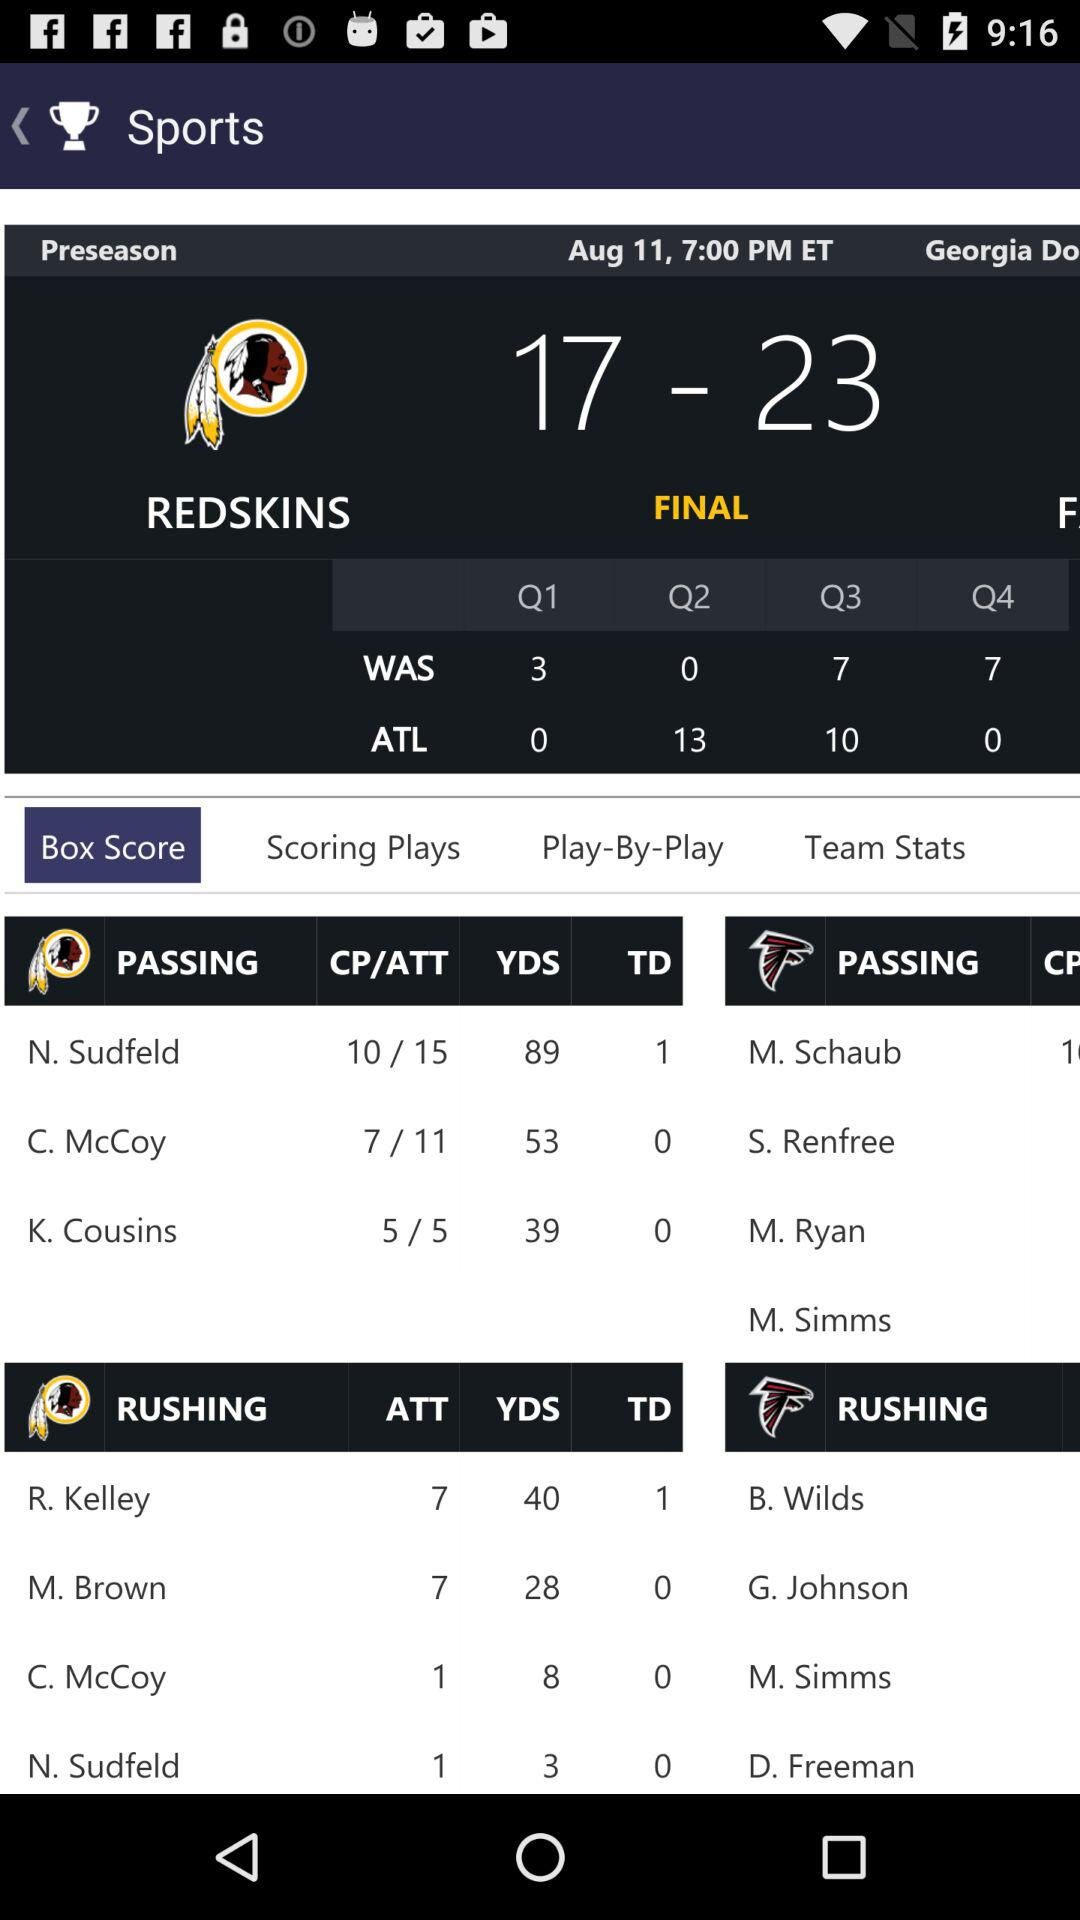What is the given date? The given date is August 11. 